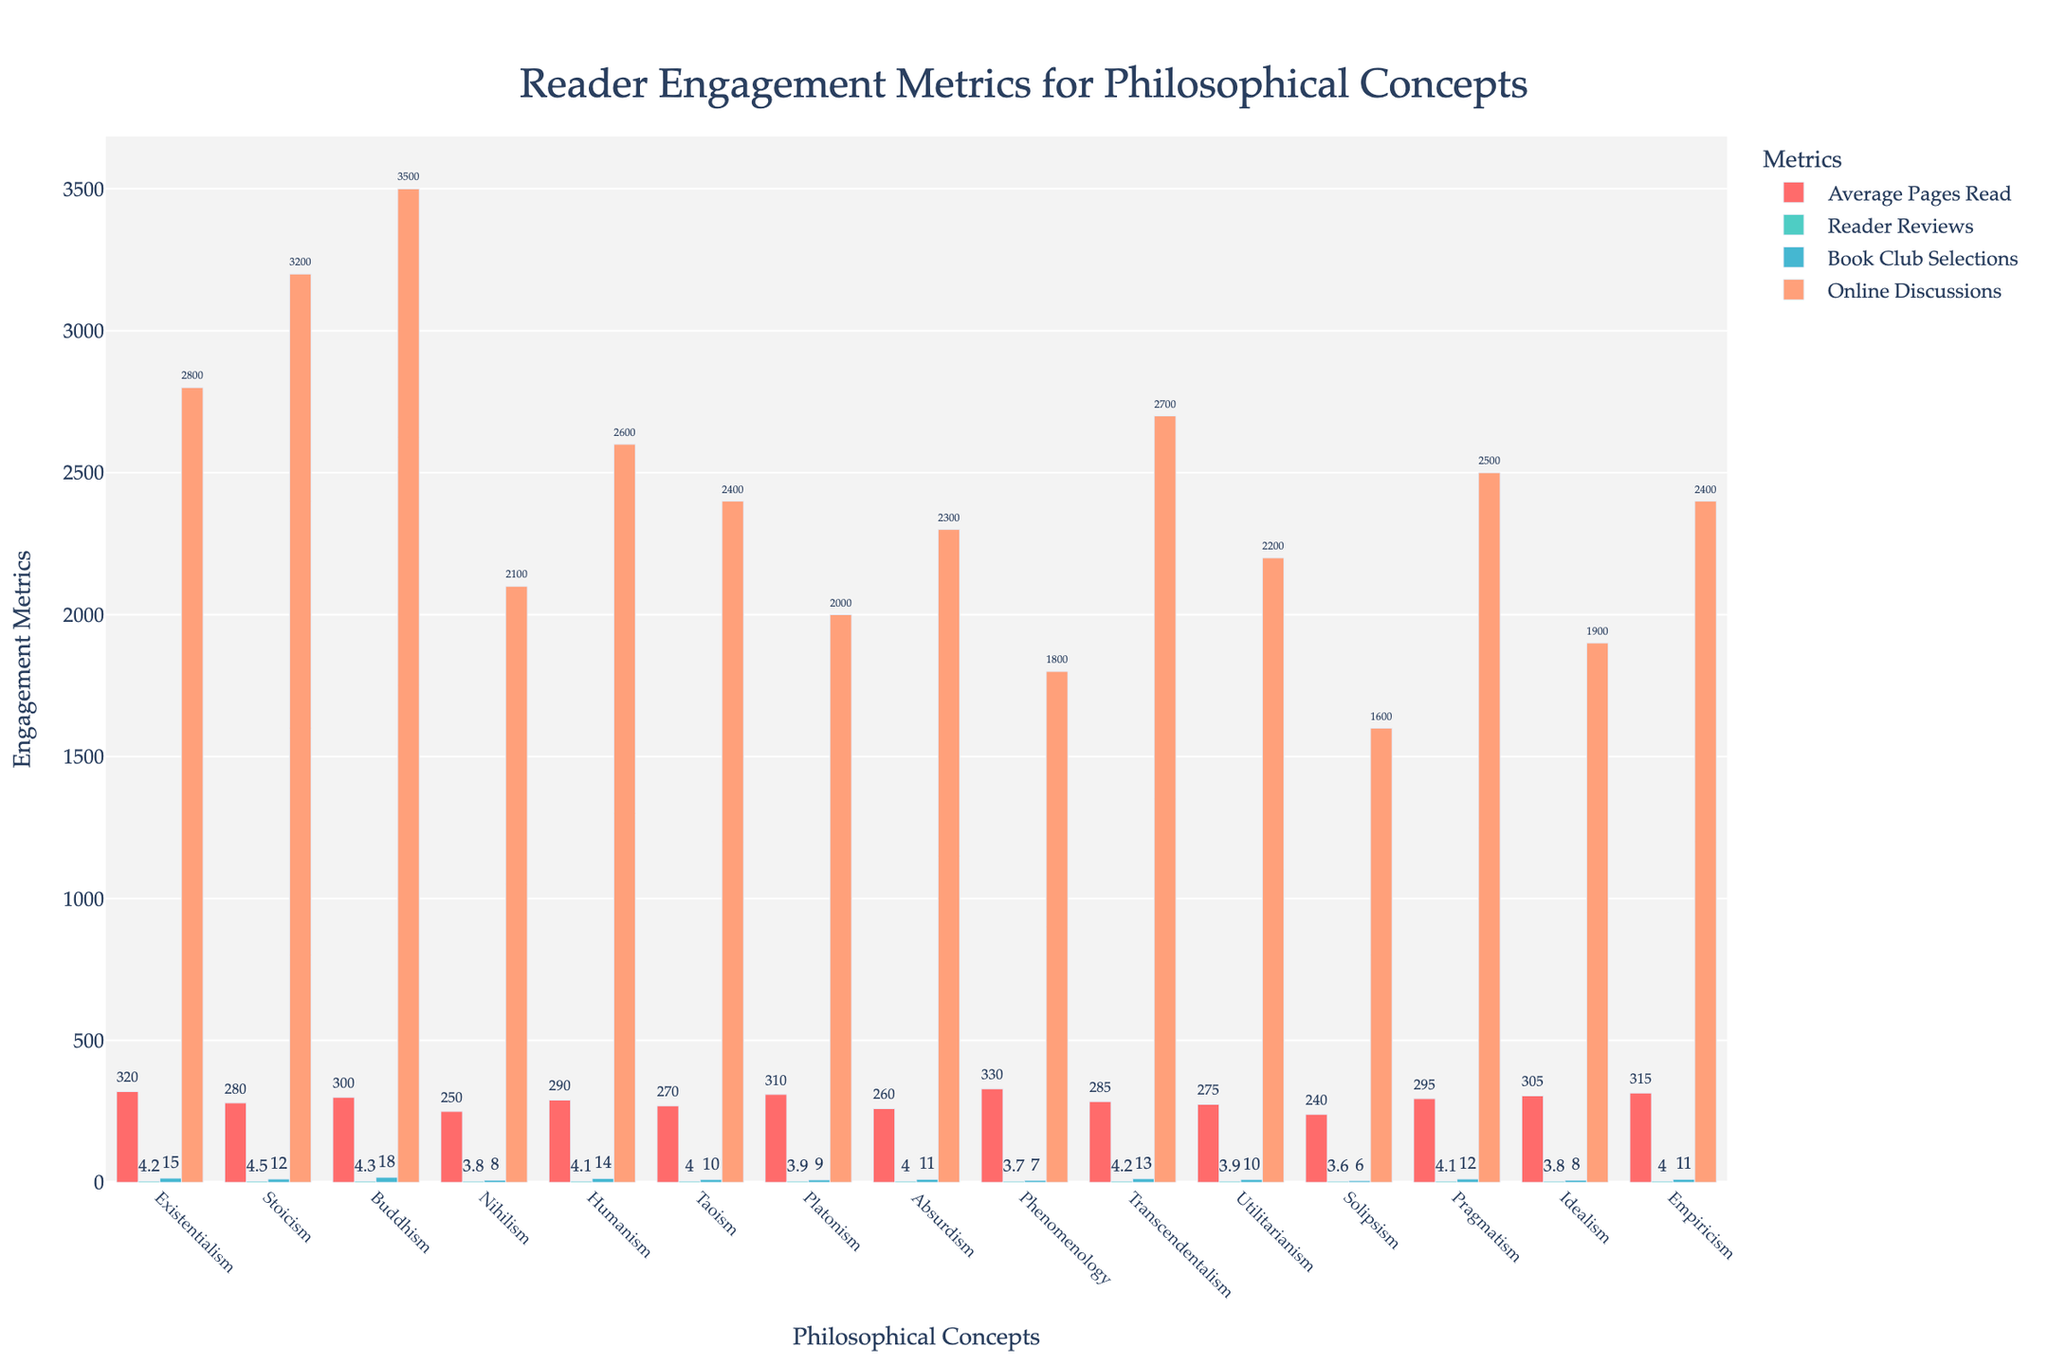Which philosophical concept has the highest average pages read? By observing the height of the bars in the 'Average Pages Read' category, the tallest bar represents the highest value. Existentialism has the highest average pages read.
Answer: Existentialism Which concept receives the highest reader reviews? By looking at the height and color-coded bars in the 'Reader Reviews' category, Stoicism has the highest reader reviews given its bar is the tallest in this metric.
Answer: Stoicism What's the total number of book club selections for Buddhism and Stoicism? Add the book club selections for Buddhism (18) and Stoicism (12). The total is 18 + 12 = 30.
Answer: 30 How does the number of online discussions for Humanism compare to that for Absurdism? Compare the height of the bars for online discussions for Humanism (2600) and Absurdism (2300). Humanism has more than Absurdism.
Answer: Humanism has more Which concept is engaged in fewer online discussions than Platonism? By examining the 'Online Discussions' category for bars lower than Platonism (2000), Phenomenology (1800) and Solipsism (1600) have fewer online discussions than Platonism.
Answer: Phenomenology and Solipsism What is the difference in the average pages read between Stoicism and Phenomenology? Subtract Stoicism's average pages read (280) from Phenomenology's (330). The difference is 330 - 280 = 50.
Answer: 50 Compare the book club selections of Idealism with Solipsism and state which has more. By looking at the height of the bars in the 'Book Club Selections' category, Idealism (8) and Solipsism (6). Idealism has more book club selections.
Answer: Idealism Which philosophical concept shows the lowest reader reviews? The lowest bar in the 'Reader Reviews' category is for Solipsism at 3.6.
Answer: Solipsism How many concepts have an average pages read greater than 300? Count the bars in the 'Average Pages Read' category above the 300 mark. Existentialism (320), Phenomenology (330), Empiricism (315), Platonism (310), and Idealism (305). There are 5 concepts.
Answer: 5 What’s the median online discussion count for all the concepts? Extract the values for online discussions and sort them: 1600, 1800, 2000, 2100, 2200, 2300, 2400, 2400, 2500, 2600, 2700, 2800, 3200, 3500. The median of the 15 values (central value) is 2400.
Answer: 2400 